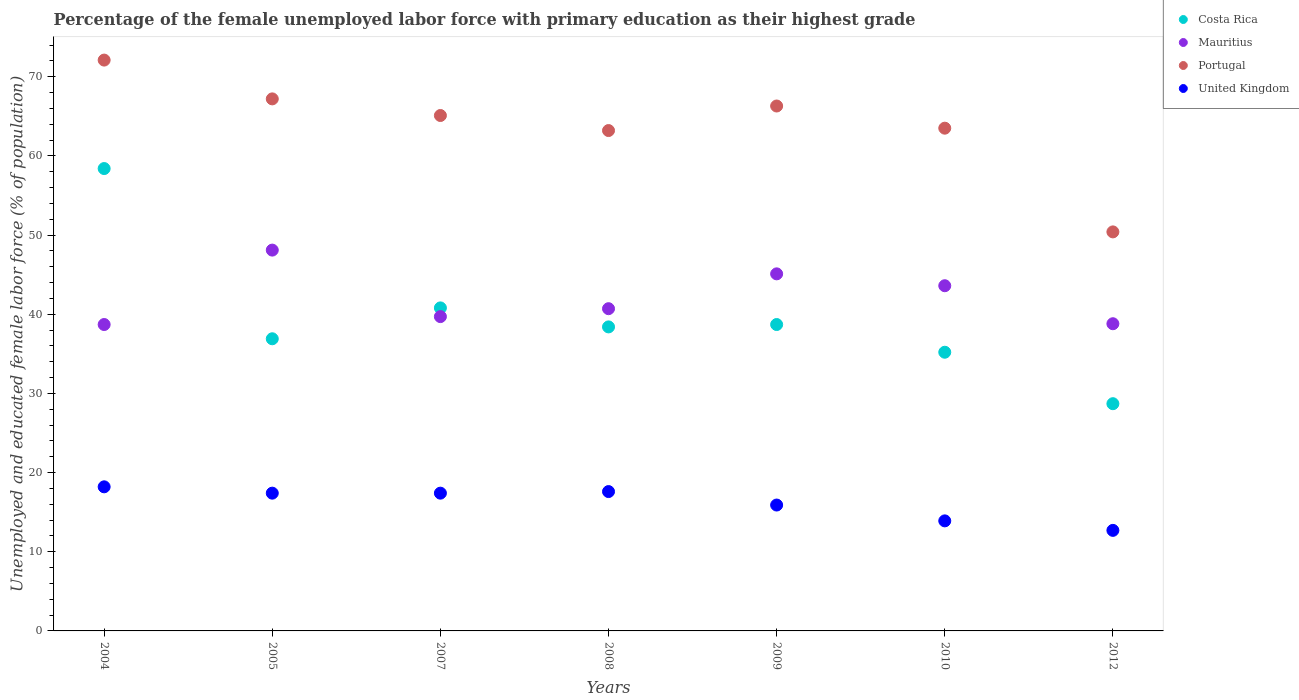How many different coloured dotlines are there?
Your answer should be compact. 4. What is the percentage of the unemployed female labor force with primary education in Mauritius in 2010?
Your answer should be very brief. 43.6. Across all years, what is the maximum percentage of the unemployed female labor force with primary education in Costa Rica?
Your answer should be compact. 58.4. Across all years, what is the minimum percentage of the unemployed female labor force with primary education in Mauritius?
Provide a succinct answer. 38.7. What is the total percentage of the unemployed female labor force with primary education in Mauritius in the graph?
Ensure brevity in your answer.  294.7. What is the difference between the percentage of the unemployed female labor force with primary education in Portugal in 2007 and that in 2009?
Your answer should be very brief. -1.2. What is the difference between the percentage of the unemployed female labor force with primary education in Costa Rica in 2008 and the percentage of the unemployed female labor force with primary education in United Kingdom in 2009?
Your response must be concise. 22.5. What is the average percentage of the unemployed female labor force with primary education in Costa Rica per year?
Keep it short and to the point. 39.59. In the year 2007, what is the difference between the percentage of the unemployed female labor force with primary education in United Kingdom and percentage of the unemployed female labor force with primary education in Portugal?
Ensure brevity in your answer.  -47.7. What is the ratio of the percentage of the unemployed female labor force with primary education in Mauritius in 2007 to that in 2008?
Your response must be concise. 0.98. Is the percentage of the unemployed female labor force with primary education in Portugal in 2004 less than that in 2008?
Make the answer very short. No. Is the difference between the percentage of the unemployed female labor force with primary education in United Kingdom in 2004 and 2005 greater than the difference between the percentage of the unemployed female labor force with primary education in Portugal in 2004 and 2005?
Your response must be concise. No. What is the difference between the highest and the second highest percentage of the unemployed female labor force with primary education in Costa Rica?
Provide a succinct answer. 17.6. What is the difference between the highest and the lowest percentage of the unemployed female labor force with primary education in United Kingdom?
Give a very brief answer. 5.5. Is it the case that in every year, the sum of the percentage of the unemployed female labor force with primary education in Mauritius and percentage of the unemployed female labor force with primary education in United Kingdom  is greater than the sum of percentage of the unemployed female labor force with primary education in Portugal and percentage of the unemployed female labor force with primary education in Costa Rica?
Provide a short and direct response. No. Are the values on the major ticks of Y-axis written in scientific E-notation?
Make the answer very short. No. Does the graph contain grids?
Offer a very short reply. No. Where does the legend appear in the graph?
Make the answer very short. Top right. How are the legend labels stacked?
Offer a very short reply. Vertical. What is the title of the graph?
Give a very brief answer. Percentage of the female unemployed labor force with primary education as their highest grade. What is the label or title of the Y-axis?
Ensure brevity in your answer.  Unemployed and educated female labor force (% of population). What is the Unemployed and educated female labor force (% of population) of Costa Rica in 2004?
Make the answer very short. 58.4. What is the Unemployed and educated female labor force (% of population) in Mauritius in 2004?
Your answer should be compact. 38.7. What is the Unemployed and educated female labor force (% of population) in Portugal in 2004?
Make the answer very short. 72.1. What is the Unemployed and educated female labor force (% of population) of United Kingdom in 2004?
Make the answer very short. 18.2. What is the Unemployed and educated female labor force (% of population) in Costa Rica in 2005?
Offer a very short reply. 36.9. What is the Unemployed and educated female labor force (% of population) in Mauritius in 2005?
Make the answer very short. 48.1. What is the Unemployed and educated female labor force (% of population) in Portugal in 2005?
Give a very brief answer. 67.2. What is the Unemployed and educated female labor force (% of population) in United Kingdom in 2005?
Provide a succinct answer. 17.4. What is the Unemployed and educated female labor force (% of population) in Costa Rica in 2007?
Make the answer very short. 40.8. What is the Unemployed and educated female labor force (% of population) of Mauritius in 2007?
Your response must be concise. 39.7. What is the Unemployed and educated female labor force (% of population) of Portugal in 2007?
Give a very brief answer. 65.1. What is the Unemployed and educated female labor force (% of population) in United Kingdom in 2007?
Your response must be concise. 17.4. What is the Unemployed and educated female labor force (% of population) of Costa Rica in 2008?
Give a very brief answer. 38.4. What is the Unemployed and educated female labor force (% of population) of Mauritius in 2008?
Your answer should be very brief. 40.7. What is the Unemployed and educated female labor force (% of population) in Portugal in 2008?
Make the answer very short. 63.2. What is the Unemployed and educated female labor force (% of population) of United Kingdom in 2008?
Your response must be concise. 17.6. What is the Unemployed and educated female labor force (% of population) of Costa Rica in 2009?
Provide a short and direct response. 38.7. What is the Unemployed and educated female labor force (% of population) in Mauritius in 2009?
Give a very brief answer. 45.1. What is the Unemployed and educated female labor force (% of population) in Portugal in 2009?
Your answer should be compact. 66.3. What is the Unemployed and educated female labor force (% of population) in United Kingdom in 2009?
Provide a succinct answer. 15.9. What is the Unemployed and educated female labor force (% of population) in Costa Rica in 2010?
Offer a terse response. 35.2. What is the Unemployed and educated female labor force (% of population) of Mauritius in 2010?
Offer a very short reply. 43.6. What is the Unemployed and educated female labor force (% of population) in Portugal in 2010?
Ensure brevity in your answer.  63.5. What is the Unemployed and educated female labor force (% of population) in United Kingdom in 2010?
Provide a succinct answer. 13.9. What is the Unemployed and educated female labor force (% of population) in Costa Rica in 2012?
Make the answer very short. 28.7. What is the Unemployed and educated female labor force (% of population) in Mauritius in 2012?
Offer a very short reply. 38.8. What is the Unemployed and educated female labor force (% of population) in Portugal in 2012?
Give a very brief answer. 50.4. What is the Unemployed and educated female labor force (% of population) of United Kingdom in 2012?
Keep it short and to the point. 12.7. Across all years, what is the maximum Unemployed and educated female labor force (% of population) of Costa Rica?
Make the answer very short. 58.4. Across all years, what is the maximum Unemployed and educated female labor force (% of population) in Mauritius?
Ensure brevity in your answer.  48.1. Across all years, what is the maximum Unemployed and educated female labor force (% of population) in Portugal?
Provide a short and direct response. 72.1. Across all years, what is the maximum Unemployed and educated female labor force (% of population) of United Kingdom?
Give a very brief answer. 18.2. Across all years, what is the minimum Unemployed and educated female labor force (% of population) in Costa Rica?
Keep it short and to the point. 28.7. Across all years, what is the minimum Unemployed and educated female labor force (% of population) of Mauritius?
Give a very brief answer. 38.7. Across all years, what is the minimum Unemployed and educated female labor force (% of population) in Portugal?
Your response must be concise. 50.4. Across all years, what is the minimum Unemployed and educated female labor force (% of population) of United Kingdom?
Ensure brevity in your answer.  12.7. What is the total Unemployed and educated female labor force (% of population) in Costa Rica in the graph?
Your answer should be very brief. 277.1. What is the total Unemployed and educated female labor force (% of population) in Mauritius in the graph?
Provide a short and direct response. 294.7. What is the total Unemployed and educated female labor force (% of population) in Portugal in the graph?
Keep it short and to the point. 447.8. What is the total Unemployed and educated female labor force (% of population) in United Kingdom in the graph?
Your answer should be very brief. 113.1. What is the difference between the Unemployed and educated female labor force (% of population) in Costa Rica in 2004 and that in 2005?
Provide a succinct answer. 21.5. What is the difference between the Unemployed and educated female labor force (% of population) of Mauritius in 2004 and that in 2005?
Give a very brief answer. -9.4. What is the difference between the Unemployed and educated female labor force (% of population) of United Kingdom in 2004 and that in 2005?
Provide a short and direct response. 0.8. What is the difference between the Unemployed and educated female labor force (% of population) in Mauritius in 2004 and that in 2007?
Offer a very short reply. -1. What is the difference between the Unemployed and educated female labor force (% of population) in United Kingdom in 2004 and that in 2007?
Offer a very short reply. 0.8. What is the difference between the Unemployed and educated female labor force (% of population) in United Kingdom in 2004 and that in 2008?
Keep it short and to the point. 0.6. What is the difference between the Unemployed and educated female labor force (% of population) in United Kingdom in 2004 and that in 2009?
Your answer should be very brief. 2.3. What is the difference between the Unemployed and educated female labor force (% of population) in Costa Rica in 2004 and that in 2010?
Offer a terse response. 23.2. What is the difference between the Unemployed and educated female labor force (% of population) in Mauritius in 2004 and that in 2010?
Give a very brief answer. -4.9. What is the difference between the Unemployed and educated female labor force (% of population) in Portugal in 2004 and that in 2010?
Your answer should be compact. 8.6. What is the difference between the Unemployed and educated female labor force (% of population) in Costa Rica in 2004 and that in 2012?
Provide a succinct answer. 29.7. What is the difference between the Unemployed and educated female labor force (% of population) in Portugal in 2004 and that in 2012?
Offer a terse response. 21.7. What is the difference between the Unemployed and educated female labor force (% of population) in United Kingdom in 2004 and that in 2012?
Ensure brevity in your answer.  5.5. What is the difference between the Unemployed and educated female labor force (% of population) of Mauritius in 2005 and that in 2007?
Keep it short and to the point. 8.4. What is the difference between the Unemployed and educated female labor force (% of population) in Portugal in 2005 and that in 2007?
Provide a succinct answer. 2.1. What is the difference between the Unemployed and educated female labor force (% of population) of United Kingdom in 2005 and that in 2007?
Provide a short and direct response. 0. What is the difference between the Unemployed and educated female labor force (% of population) in Mauritius in 2005 and that in 2008?
Your response must be concise. 7.4. What is the difference between the Unemployed and educated female labor force (% of population) in Portugal in 2005 and that in 2008?
Give a very brief answer. 4. What is the difference between the Unemployed and educated female labor force (% of population) in United Kingdom in 2005 and that in 2008?
Offer a very short reply. -0.2. What is the difference between the Unemployed and educated female labor force (% of population) in Mauritius in 2005 and that in 2010?
Make the answer very short. 4.5. What is the difference between the Unemployed and educated female labor force (% of population) in Portugal in 2005 and that in 2010?
Provide a succinct answer. 3.7. What is the difference between the Unemployed and educated female labor force (% of population) of United Kingdom in 2005 and that in 2010?
Make the answer very short. 3.5. What is the difference between the Unemployed and educated female labor force (% of population) of Costa Rica in 2005 and that in 2012?
Keep it short and to the point. 8.2. What is the difference between the Unemployed and educated female labor force (% of population) of Portugal in 2005 and that in 2012?
Give a very brief answer. 16.8. What is the difference between the Unemployed and educated female labor force (% of population) of United Kingdom in 2005 and that in 2012?
Offer a very short reply. 4.7. What is the difference between the Unemployed and educated female labor force (% of population) in Costa Rica in 2007 and that in 2010?
Offer a terse response. 5.6. What is the difference between the Unemployed and educated female labor force (% of population) in Mauritius in 2007 and that in 2010?
Provide a succinct answer. -3.9. What is the difference between the Unemployed and educated female labor force (% of population) in Portugal in 2007 and that in 2010?
Keep it short and to the point. 1.6. What is the difference between the Unemployed and educated female labor force (% of population) of United Kingdom in 2007 and that in 2010?
Ensure brevity in your answer.  3.5. What is the difference between the Unemployed and educated female labor force (% of population) of Mauritius in 2007 and that in 2012?
Give a very brief answer. 0.9. What is the difference between the Unemployed and educated female labor force (% of population) in Portugal in 2007 and that in 2012?
Your answer should be very brief. 14.7. What is the difference between the Unemployed and educated female labor force (% of population) in United Kingdom in 2007 and that in 2012?
Offer a terse response. 4.7. What is the difference between the Unemployed and educated female labor force (% of population) of Mauritius in 2008 and that in 2009?
Provide a succinct answer. -4.4. What is the difference between the Unemployed and educated female labor force (% of population) of Mauritius in 2008 and that in 2010?
Ensure brevity in your answer.  -2.9. What is the difference between the Unemployed and educated female labor force (% of population) of United Kingdom in 2008 and that in 2010?
Offer a terse response. 3.7. What is the difference between the Unemployed and educated female labor force (% of population) in Mauritius in 2008 and that in 2012?
Your answer should be very brief. 1.9. What is the difference between the Unemployed and educated female labor force (% of population) of Portugal in 2008 and that in 2012?
Offer a very short reply. 12.8. What is the difference between the Unemployed and educated female labor force (% of population) in United Kingdom in 2008 and that in 2012?
Give a very brief answer. 4.9. What is the difference between the Unemployed and educated female labor force (% of population) in Costa Rica in 2009 and that in 2010?
Offer a very short reply. 3.5. What is the difference between the Unemployed and educated female labor force (% of population) of Mauritius in 2009 and that in 2010?
Give a very brief answer. 1.5. What is the difference between the Unemployed and educated female labor force (% of population) in Portugal in 2009 and that in 2010?
Your answer should be very brief. 2.8. What is the difference between the Unemployed and educated female labor force (% of population) in Costa Rica in 2010 and that in 2012?
Offer a terse response. 6.5. What is the difference between the Unemployed and educated female labor force (% of population) of Portugal in 2010 and that in 2012?
Offer a very short reply. 13.1. What is the difference between the Unemployed and educated female labor force (% of population) of United Kingdom in 2010 and that in 2012?
Give a very brief answer. 1.2. What is the difference between the Unemployed and educated female labor force (% of population) of Mauritius in 2004 and the Unemployed and educated female labor force (% of population) of Portugal in 2005?
Give a very brief answer. -28.5. What is the difference between the Unemployed and educated female labor force (% of population) of Mauritius in 2004 and the Unemployed and educated female labor force (% of population) of United Kingdom in 2005?
Your answer should be very brief. 21.3. What is the difference between the Unemployed and educated female labor force (% of population) in Portugal in 2004 and the Unemployed and educated female labor force (% of population) in United Kingdom in 2005?
Offer a very short reply. 54.7. What is the difference between the Unemployed and educated female labor force (% of population) of Costa Rica in 2004 and the Unemployed and educated female labor force (% of population) of Mauritius in 2007?
Offer a terse response. 18.7. What is the difference between the Unemployed and educated female labor force (% of population) in Costa Rica in 2004 and the Unemployed and educated female labor force (% of population) in Portugal in 2007?
Provide a short and direct response. -6.7. What is the difference between the Unemployed and educated female labor force (% of population) of Costa Rica in 2004 and the Unemployed and educated female labor force (% of population) of United Kingdom in 2007?
Provide a succinct answer. 41. What is the difference between the Unemployed and educated female labor force (% of population) of Mauritius in 2004 and the Unemployed and educated female labor force (% of population) of Portugal in 2007?
Your answer should be very brief. -26.4. What is the difference between the Unemployed and educated female labor force (% of population) of Mauritius in 2004 and the Unemployed and educated female labor force (% of population) of United Kingdom in 2007?
Your response must be concise. 21.3. What is the difference between the Unemployed and educated female labor force (% of population) of Portugal in 2004 and the Unemployed and educated female labor force (% of population) of United Kingdom in 2007?
Your answer should be very brief. 54.7. What is the difference between the Unemployed and educated female labor force (% of population) of Costa Rica in 2004 and the Unemployed and educated female labor force (% of population) of Mauritius in 2008?
Provide a short and direct response. 17.7. What is the difference between the Unemployed and educated female labor force (% of population) of Costa Rica in 2004 and the Unemployed and educated female labor force (% of population) of United Kingdom in 2008?
Offer a very short reply. 40.8. What is the difference between the Unemployed and educated female labor force (% of population) of Mauritius in 2004 and the Unemployed and educated female labor force (% of population) of Portugal in 2008?
Your answer should be compact. -24.5. What is the difference between the Unemployed and educated female labor force (% of population) of Mauritius in 2004 and the Unemployed and educated female labor force (% of population) of United Kingdom in 2008?
Your response must be concise. 21.1. What is the difference between the Unemployed and educated female labor force (% of population) of Portugal in 2004 and the Unemployed and educated female labor force (% of population) of United Kingdom in 2008?
Your response must be concise. 54.5. What is the difference between the Unemployed and educated female labor force (% of population) in Costa Rica in 2004 and the Unemployed and educated female labor force (% of population) in Mauritius in 2009?
Give a very brief answer. 13.3. What is the difference between the Unemployed and educated female labor force (% of population) in Costa Rica in 2004 and the Unemployed and educated female labor force (% of population) in United Kingdom in 2009?
Your response must be concise. 42.5. What is the difference between the Unemployed and educated female labor force (% of population) of Mauritius in 2004 and the Unemployed and educated female labor force (% of population) of Portugal in 2009?
Provide a succinct answer. -27.6. What is the difference between the Unemployed and educated female labor force (% of population) in Mauritius in 2004 and the Unemployed and educated female labor force (% of population) in United Kingdom in 2009?
Offer a very short reply. 22.8. What is the difference between the Unemployed and educated female labor force (% of population) of Portugal in 2004 and the Unemployed and educated female labor force (% of population) of United Kingdom in 2009?
Make the answer very short. 56.2. What is the difference between the Unemployed and educated female labor force (% of population) in Costa Rica in 2004 and the Unemployed and educated female labor force (% of population) in Portugal in 2010?
Provide a short and direct response. -5.1. What is the difference between the Unemployed and educated female labor force (% of population) in Costa Rica in 2004 and the Unemployed and educated female labor force (% of population) in United Kingdom in 2010?
Your answer should be compact. 44.5. What is the difference between the Unemployed and educated female labor force (% of population) of Mauritius in 2004 and the Unemployed and educated female labor force (% of population) of Portugal in 2010?
Provide a succinct answer. -24.8. What is the difference between the Unemployed and educated female labor force (% of population) of Mauritius in 2004 and the Unemployed and educated female labor force (% of population) of United Kingdom in 2010?
Keep it short and to the point. 24.8. What is the difference between the Unemployed and educated female labor force (% of population) in Portugal in 2004 and the Unemployed and educated female labor force (% of population) in United Kingdom in 2010?
Your answer should be compact. 58.2. What is the difference between the Unemployed and educated female labor force (% of population) in Costa Rica in 2004 and the Unemployed and educated female labor force (% of population) in Mauritius in 2012?
Your response must be concise. 19.6. What is the difference between the Unemployed and educated female labor force (% of population) of Costa Rica in 2004 and the Unemployed and educated female labor force (% of population) of Portugal in 2012?
Offer a terse response. 8. What is the difference between the Unemployed and educated female labor force (% of population) in Costa Rica in 2004 and the Unemployed and educated female labor force (% of population) in United Kingdom in 2012?
Ensure brevity in your answer.  45.7. What is the difference between the Unemployed and educated female labor force (% of population) of Portugal in 2004 and the Unemployed and educated female labor force (% of population) of United Kingdom in 2012?
Your response must be concise. 59.4. What is the difference between the Unemployed and educated female labor force (% of population) in Costa Rica in 2005 and the Unemployed and educated female labor force (% of population) in Mauritius in 2007?
Your answer should be compact. -2.8. What is the difference between the Unemployed and educated female labor force (% of population) in Costa Rica in 2005 and the Unemployed and educated female labor force (% of population) in Portugal in 2007?
Provide a succinct answer. -28.2. What is the difference between the Unemployed and educated female labor force (% of population) in Mauritius in 2005 and the Unemployed and educated female labor force (% of population) in United Kingdom in 2007?
Your answer should be very brief. 30.7. What is the difference between the Unemployed and educated female labor force (% of population) in Portugal in 2005 and the Unemployed and educated female labor force (% of population) in United Kingdom in 2007?
Keep it short and to the point. 49.8. What is the difference between the Unemployed and educated female labor force (% of population) in Costa Rica in 2005 and the Unemployed and educated female labor force (% of population) in Mauritius in 2008?
Ensure brevity in your answer.  -3.8. What is the difference between the Unemployed and educated female labor force (% of population) of Costa Rica in 2005 and the Unemployed and educated female labor force (% of population) of Portugal in 2008?
Provide a succinct answer. -26.3. What is the difference between the Unemployed and educated female labor force (% of population) of Costa Rica in 2005 and the Unemployed and educated female labor force (% of population) of United Kingdom in 2008?
Provide a short and direct response. 19.3. What is the difference between the Unemployed and educated female labor force (% of population) of Mauritius in 2005 and the Unemployed and educated female labor force (% of population) of Portugal in 2008?
Make the answer very short. -15.1. What is the difference between the Unemployed and educated female labor force (% of population) of Mauritius in 2005 and the Unemployed and educated female labor force (% of population) of United Kingdom in 2008?
Keep it short and to the point. 30.5. What is the difference between the Unemployed and educated female labor force (% of population) of Portugal in 2005 and the Unemployed and educated female labor force (% of population) of United Kingdom in 2008?
Offer a very short reply. 49.6. What is the difference between the Unemployed and educated female labor force (% of population) in Costa Rica in 2005 and the Unemployed and educated female labor force (% of population) in Portugal in 2009?
Offer a terse response. -29.4. What is the difference between the Unemployed and educated female labor force (% of population) of Costa Rica in 2005 and the Unemployed and educated female labor force (% of population) of United Kingdom in 2009?
Your answer should be compact. 21. What is the difference between the Unemployed and educated female labor force (% of population) in Mauritius in 2005 and the Unemployed and educated female labor force (% of population) in Portugal in 2009?
Offer a very short reply. -18.2. What is the difference between the Unemployed and educated female labor force (% of population) in Mauritius in 2005 and the Unemployed and educated female labor force (% of population) in United Kingdom in 2009?
Your answer should be very brief. 32.2. What is the difference between the Unemployed and educated female labor force (% of population) in Portugal in 2005 and the Unemployed and educated female labor force (% of population) in United Kingdom in 2009?
Make the answer very short. 51.3. What is the difference between the Unemployed and educated female labor force (% of population) in Costa Rica in 2005 and the Unemployed and educated female labor force (% of population) in Portugal in 2010?
Make the answer very short. -26.6. What is the difference between the Unemployed and educated female labor force (% of population) of Costa Rica in 2005 and the Unemployed and educated female labor force (% of population) of United Kingdom in 2010?
Your response must be concise. 23. What is the difference between the Unemployed and educated female labor force (% of population) in Mauritius in 2005 and the Unemployed and educated female labor force (% of population) in Portugal in 2010?
Make the answer very short. -15.4. What is the difference between the Unemployed and educated female labor force (% of population) of Mauritius in 2005 and the Unemployed and educated female labor force (% of population) of United Kingdom in 2010?
Your answer should be very brief. 34.2. What is the difference between the Unemployed and educated female labor force (% of population) of Portugal in 2005 and the Unemployed and educated female labor force (% of population) of United Kingdom in 2010?
Keep it short and to the point. 53.3. What is the difference between the Unemployed and educated female labor force (% of population) in Costa Rica in 2005 and the Unemployed and educated female labor force (% of population) in Mauritius in 2012?
Offer a terse response. -1.9. What is the difference between the Unemployed and educated female labor force (% of population) in Costa Rica in 2005 and the Unemployed and educated female labor force (% of population) in Portugal in 2012?
Offer a very short reply. -13.5. What is the difference between the Unemployed and educated female labor force (% of population) of Costa Rica in 2005 and the Unemployed and educated female labor force (% of population) of United Kingdom in 2012?
Offer a terse response. 24.2. What is the difference between the Unemployed and educated female labor force (% of population) of Mauritius in 2005 and the Unemployed and educated female labor force (% of population) of United Kingdom in 2012?
Provide a short and direct response. 35.4. What is the difference between the Unemployed and educated female labor force (% of population) in Portugal in 2005 and the Unemployed and educated female labor force (% of population) in United Kingdom in 2012?
Your response must be concise. 54.5. What is the difference between the Unemployed and educated female labor force (% of population) of Costa Rica in 2007 and the Unemployed and educated female labor force (% of population) of Mauritius in 2008?
Provide a succinct answer. 0.1. What is the difference between the Unemployed and educated female labor force (% of population) of Costa Rica in 2007 and the Unemployed and educated female labor force (% of population) of Portugal in 2008?
Your response must be concise. -22.4. What is the difference between the Unemployed and educated female labor force (% of population) in Costa Rica in 2007 and the Unemployed and educated female labor force (% of population) in United Kingdom in 2008?
Make the answer very short. 23.2. What is the difference between the Unemployed and educated female labor force (% of population) in Mauritius in 2007 and the Unemployed and educated female labor force (% of population) in Portugal in 2008?
Provide a short and direct response. -23.5. What is the difference between the Unemployed and educated female labor force (% of population) in Mauritius in 2007 and the Unemployed and educated female labor force (% of population) in United Kingdom in 2008?
Provide a succinct answer. 22.1. What is the difference between the Unemployed and educated female labor force (% of population) of Portugal in 2007 and the Unemployed and educated female labor force (% of population) of United Kingdom in 2008?
Your answer should be compact. 47.5. What is the difference between the Unemployed and educated female labor force (% of population) of Costa Rica in 2007 and the Unemployed and educated female labor force (% of population) of Portugal in 2009?
Provide a succinct answer. -25.5. What is the difference between the Unemployed and educated female labor force (% of population) of Costa Rica in 2007 and the Unemployed and educated female labor force (% of population) of United Kingdom in 2009?
Keep it short and to the point. 24.9. What is the difference between the Unemployed and educated female labor force (% of population) of Mauritius in 2007 and the Unemployed and educated female labor force (% of population) of Portugal in 2009?
Your answer should be very brief. -26.6. What is the difference between the Unemployed and educated female labor force (% of population) in Mauritius in 2007 and the Unemployed and educated female labor force (% of population) in United Kingdom in 2009?
Your response must be concise. 23.8. What is the difference between the Unemployed and educated female labor force (% of population) of Portugal in 2007 and the Unemployed and educated female labor force (% of population) of United Kingdom in 2009?
Provide a short and direct response. 49.2. What is the difference between the Unemployed and educated female labor force (% of population) of Costa Rica in 2007 and the Unemployed and educated female labor force (% of population) of Portugal in 2010?
Offer a very short reply. -22.7. What is the difference between the Unemployed and educated female labor force (% of population) in Costa Rica in 2007 and the Unemployed and educated female labor force (% of population) in United Kingdom in 2010?
Ensure brevity in your answer.  26.9. What is the difference between the Unemployed and educated female labor force (% of population) in Mauritius in 2007 and the Unemployed and educated female labor force (% of population) in Portugal in 2010?
Keep it short and to the point. -23.8. What is the difference between the Unemployed and educated female labor force (% of population) of Mauritius in 2007 and the Unemployed and educated female labor force (% of population) of United Kingdom in 2010?
Your answer should be very brief. 25.8. What is the difference between the Unemployed and educated female labor force (% of population) of Portugal in 2007 and the Unemployed and educated female labor force (% of population) of United Kingdom in 2010?
Provide a short and direct response. 51.2. What is the difference between the Unemployed and educated female labor force (% of population) of Costa Rica in 2007 and the Unemployed and educated female labor force (% of population) of Mauritius in 2012?
Offer a terse response. 2. What is the difference between the Unemployed and educated female labor force (% of population) in Costa Rica in 2007 and the Unemployed and educated female labor force (% of population) in Portugal in 2012?
Your response must be concise. -9.6. What is the difference between the Unemployed and educated female labor force (% of population) of Costa Rica in 2007 and the Unemployed and educated female labor force (% of population) of United Kingdom in 2012?
Your response must be concise. 28.1. What is the difference between the Unemployed and educated female labor force (% of population) of Mauritius in 2007 and the Unemployed and educated female labor force (% of population) of Portugal in 2012?
Ensure brevity in your answer.  -10.7. What is the difference between the Unemployed and educated female labor force (% of population) of Portugal in 2007 and the Unemployed and educated female labor force (% of population) of United Kingdom in 2012?
Keep it short and to the point. 52.4. What is the difference between the Unemployed and educated female labor force (% of population) in Costa Rica in 2008 and the Unemployed and educated female labor force (% of population) in Portugal in 2009?
Offer a terse response. -27.9. What is the difference between the Unemployed and educated female labor force (% of population) in Costa Rica in 2008 and the Unemployed and educated female labor force (% of population) in United Kingdom in 2009?
Provide a succinct answer. 22.5. What is the difference between the Unemployed and educated female labor force (% of population) of Mauritius in 2008 and the Unemployed and educated female labor force (% of population) of Portugal in 2009?
Provide a short and direct response. -25.6. What is the difference between the Unemployed and educated female labor force (% of population) in Mauritius in 2008 and the Unemployed and educated female labor force (% of population) in United Kingdom in 2009?
Keep it short and to the point. 24.8. What is the difference between the Unemployed and educated female labor force (% of population) in Portugal in 2008 and the Unemployed and educated female labor force (% of population) in United Kingdom in 2009?
Provide a short and direct response. 47.3. What is the difference between the Unemployed and educated female labor force (% of population) in Costa Rica in 2008 and the Unemployed and educated female labor force (% of population) in Mauritius in 2010?
Offer a terse response. -5.2. What is the difference between the Unemployed and educated female labor force (% of population) in Costa Rica in 2008 and the Unemployed and educated female labor force (% of population) in Portugal in 2010?
Provide a short and direct response. -25.1. What is the difference between the Unemployed and educated female labor force (% of population) of Mauritius in 2008 and the Unemployed and educated female labor force (% of population) of Portugal in 2010?
Provide a succinct answer. -22.8. What is the difference between the Unemployed and educated female labor force (% of population) of Mauritius in 2008 and the Unemployed and educated female labor force (% of population) of United Kingdom in 2010?
Offer a very short reply. 26.8. What is the difference between the Unemployed and educated female labor force (% of population) of Portugal in 2008 and the Unemployed and educated female labor force (% of population) of United Kingdom in 2010?
Your answer should be compact. 49.3. What is the difference between the Unemployed and educated female labor force (% of population) in Costa Rica in 2008 and the Unemployed and educated female labor force (% of population) in United Kingdom in 2012?
Offer a very short reply. 25.7. What is the difference between the Unemployed and educated female labor force (% of population) of Portugal in 2008 and the Unemployed and educated female labor force (% of population) of United Kingdom in 2012?
Offer a terse response. 50.5. What is the difference between the Unemployed and educated female labor force (% of population) in Costa Rica in 2009 and the Unemployed and educated female labor force (% of population) in Portugal in 2010?
Your answer should be very brief. -24.8. What is the difference between the Unemployed and educated female labor force (% of population) in Costa Rica in 2009 and the Unemployed and educated female labor force (% of population) in United Kingdom in 2010?
Make the answer very short. 24.8. What is the difference between the Unemployed and educated female labor force (% of population) of Mauritius in 2009 and the Unemployed and educated female labor force (% of population) of Portugal in 2010?
Offer a terse response. -18.4. What is the difference between the Unemployed and educated female labor force (% of population) in Mauritius in 2009 and the Unemployed and educated female labor force (% of population) in United Kingdom in 2010?
Your response must be concise. 31.2. What is the difference between the Unemployed and educated female labor force (% of population) of Portugal in 2009 and the Unemployed and educated female labor force (% of population) of United Kingdom in 2010?
Offer a terse response. 52.4. What is the difference between the Unemployed and educated female labor force (% of population) of Costa Rica in 2009 and the Unemployed and educated female labor force (% of population) of United Kingdom in 2012?
Offer a very short reply. 26. What is the difference between the Unemployed and educated female labor force (% of population) of Mauritius in 2009 and the Unemployed and educated female labor force (% of population) of United Kingdom in 2012?
Provide a short and direct response. 32.4. What is the difference between the Unemployed and educated female labor force (% of population) of Portugal in 2009 and the Unemployed and educated female labor force (% of population) of United Kingdom in 2012?
Your response must be concise. 53.6. What is the difference between the Unemployed and educated female labor force (% of population) of Costa Rica in 2010 and the Unemployed and educated female labor force (% of population) of Portugal in 2012?
Offer a terse response. -15.2. What is the difference between the Unemployed and educated female labor force (% of population) of Mauritius in 2010 and the Unemployed and educated female labor force (% of population) of United Kingdom in 2012?
Offer a very short reply. 30.9. What is the difference between the Unemployed and educated female labor force (% of population) in Portugal in 2010 and the Unemployed and educated female labor force (% of population) in United Kingdom in 2012?
Make the answer very short. 50.8. What is the average Unemployed and educated female labor force (% of population) of Costa Rica per year?
Provide a short and direct response. 39.59. What is the average Unemployed and educated female labor force (% of population) in Mauritius per year?
Make the answer very short. 42.1. What is the average Unemployed and educated female labor force (% of population) of Portugal per year?
Offer a very short reply. 63.97. What is the average Unemployed and educated female labor force (% of population) in United Kingdom per year?
Your answer should be very brief. 16.16. In the year 2004, what is the difference between the Unemployed and educated female labor force (% of population) of Costa Rica and Unemployed and educated female labor force (% of population) of Mauritius?
Offer a terse response. 19.7. In the year 2004, what is the difference between the Unemployed and educated female labor force (% of population) in Costa Rica and Unemployed and educated female labor force (% of population) in Portugal?
Offer a very short reply. -13.7. In the year 2004, what is the difference between the Unemployed and educated female labor force (% of population) in Costa Rica and Unemployed and educated female labor force (% of population) in United Kingdom?
Make the answer very short. 40.2. In the year 2004, what is the difference between the Unemployed and educated female labor force (% of population) of Mauritius and Unemployed and educated female labor force (% of population) of Portugal?
Give a very brief answer. -33.4. In the year 2004, what is the difference between the Unemployed and educated female labor force (% of population) in Mauritius and Unemployed and educated female labor force (% of population) in United Kingdom?
Give a very brief answer. 20.5. In the year 2004, what is the difference between the Unemployed and educated female labor force (% of population) of Portugal and Unemployed and educated female labor force (% of population) of United Kingdom?
Your answer should be compact. 53.9. In the year 2005, what is the difference between the Unemployed and educated female labor force (% of population) in Costa Rica and Unemployed and educated female labor force (% of population) in Mauritius?
Make the answer very short. -11.2. In the year 2005, what is the difference between the Unemployed and educated female labor force (% of population) in Costa Rica and Unemployed and educated female labor force (% of population) in Portugal?
Provide a short and direct response. -30.3. In the year 2005, what is the difference between the Unemployed and educated female labor force (% of population) in Costa Rica and Unemployed and educated female labor force (% of population) in United Kingdom?
Offer a very short reply. 19.5. In the year 2005, what is the difference between the Unemployed and educated female labor force (% of population) of Mauritius and Unemployed and educated female labor force (% of population) of Portugal?
Offer a very short reply. -19.1. In the year 2005, what is the difference between the Unemployed and educated female labor force (% of population) in Mauritius and Unemployed and educated female labor force (% of population) in United Kingdom?
Offer a terse response. 30.7. In the year 2005, what is the difference between the Unemployed and educated female labor force (% of population) in Portugal and Unemployed and educated female labor force (% of population) in United Kingdom?
Your answer should be very brief. 49.8. In the year 2007, what is the difference between the Unemployed and educated female labor force (% of population) in Costa Rica and Unemployed and educated female labor force (% of population) in Mauritius?
Provide a short and direct response. 1.1. In the year 2007, what is the difference between the Unemployed and educated female labor force (% of population) in Costa Rica and Unemployed and educated female labor force (% of population) in Portugal?
Offer a terse response. -24.3. In the year 2007, what is the difference between the Unemployed and educated female labor force (% of population) of Costa Rica and Unemployed and educated female labor force (% of population) of United Kingdom?
Offer a very short reply. 23.4. In the year 2007, what is the difference between the Unemployed and educated female labor force (% of population) of Mauritius and Unemployed and educated female labor force (% of population) of Portugal?
Give a very brief answer. -25.4. In the year 2007, what is the difference between the Unemployed and educated female labor force (% of population) of Mauritius and Unemployed and educated female labor force (% of population) of United Kingdom?
Keep it short and to the point. 22.3. In the year 2007, what is the difference between the Unemployed and educated female labor force (% of population) of Portugal and Unemployed and educated female labor force (% of population) of United Kingdom?
Offer a very short reply. 47.7. In the year 2008, what is the difference between the Unemployed and educated female labor force (% of population) in Costa Rica and Unemployed and educated female labor force (% of population) in Mauritius?
Your answer should be compact. -2.3. In the year 2008, what is the difference between the Unemployed and educated female labor force (% of population) in Costa Rica and Unemployed and educated female labor force (% of population) in Portugal?
Your answer should be very brief. -24.8. In the year 2008, what is the difference between the Unemployed and educated female labor force (% of population) in Costa Rica and Unemployed and educated female labor force (% of population) in United Kingdom?
Provide a succinct answer. 20.8. In the year 2008, what is the difference between the Unemployed and educated female labor force (% of population) of Mauritius and Unemployed and educated female labor force (% of population) of Portugal?
Make the answer very short. -22.5. In the year 2008, what is the difference between the Unemployed and educated female labor force (% of population) in Mauritius and Unemployed and educated female labor force (% of population) in United Kingdom?
Offer a very short reply. 23.1. In the year 2008, what is the difference between the Unemployed and educated female labor force (% of population) of Portugal and Unemployed and educated female labor force (% of population) of United Kingdom?
Provide a succinct answer. 45.6. In the year 2009, what is the difference between the Unemployed and educated female labor force (% of population) in Costa Rica and Unemployed and educated female labor force (% of population) in Portugal?
Provide a short and direct response. -27.6. In the year 2009, what is the difference between the Unemployed and educated female labor force (% of population) in Costa Rica and Unemployed and educated female labor force (% of population) in United Kingdom?
Give a very brief answer. 22.8. In the year 2009, what is the difference between the Unemployed and educated female labor force (% of population) in Mauritius and Unemployed and educated female labor force (% of population) in Portugal?
Keep it short and to the point. -21.2. In the year 2009, what is the difference between the Unemployed and educated female labor force (% of population) of Mauritius and Unemployed and educated female labor force (% of population) of United Kingdom?
Ensure brevity in your answer.  29.2. In the year 2009, what is the difference between the Unemployed and educated female labor force (% of population) in Portugal and Unemployed and educated female labor force (% of population) in United Kingdom?
Your response must be concise. 50.4. In the year 2010, what is the difference between the Unemployed and educated female labor force (% of population) in Costa Rica and Unemployed and educated female labor force (% of population) in Portugal?
Your answer should be compact. -28.3. In the year 2010, what is the difference between the Unemployed and educated female labor force (% of population) of Costa Rica and Unemployed and educated female labor force (% of population) of United Kingdom?
Offer a terse response. 21.3. In the year 2010, what is the difference between the Unemployed and educated female labor force (% of population) in Mauritius and Unemployed and educated female labor force (% of population) in Portugal?
Your response must be concise. -19.9. In the year 2010, what is the difference between the Unemployed and educated female labor force (% of population) in Mauritius and Unemployed and educated female labor force (% of population) in United Kingdom?
Provide a short and direct response. 29.7. In the year 2010, what is the difference between the Unemployed and educated female labor force (% of population) in Portugal and Unemployed and educated female labor force (% of population) in United Kingdom?
Your answer should be compact. 49.6. In the year 2012, what is the difference between the Unemployed and educated female labor force (% of population) in Costa Rica and Unemployed and educated female labor force (% of population) in Portugal?
Make the answer very short. -21.7. In the year 2012, what is the difference between the Unemployed and educated female labor force (% of population) of Mauritius and Unemployed and educated female labor force (% of population) of Portugal?
Give a very brief answer. -11.6. In the year 2012, what is the difference between the Unemployed and educated female labor force (% of population) in Mauritius and Unemployed and educated female labor force (% of population) in United Kingdom?
Make the answer very short. 26.1. In the year 2012, what is the difference between the Unemployed and educated female labor force (% of population) of Portugal and Unemployed and educated female labor force (% of population) of United Kingdom?
Provide a short and direct response. 37.7. What is the ratio of the Unemployed and educated female labor force (% of population) of Costa Rica in 2004 to that in 2005?
Provide a succinct answer. 1.58. What is the ratio of the Unemployed and educated female labor force (% of population) in Mauritius in 2004 to that in 2005?
Keep it short and to the point. 0.8. What is the ratio of the Unemployed and educated female labor force (% of population) in Portugal in 2004 to that in 2005?
Your answer should be very brief. 1.07. What is the ratio of the Unemployed and educated female labor force (% of population) in United Kingdom in 2004 to that in 2005?
Provide a succinct answer. 1.05. What is the ratio of the Unemployed and educated female labor force (% of population) of Costa Rica in 2004 to that in 2007?
Offer a very short reply. 1.43. What is the ratio of the Unemployed and educated female labor force (% of population) in Mauritius in 2004 to that in 2007?
Give a very brief answer. 0.97. What is the ratio of the Unemployed and educated female labor force (% of population) of Portugal in 2004 to that in 2007?
Offer a terse response. 1.11. What is the ratio of the Unemployed and educated female labor force (% of population) in United Kingdom in 2004 to that in 2007?
Make the answer very short. 1.05. What is the ratio of the Unemployed and educated female labor force (% of population) in Costa Rica in 2004 to that in 2008?
Ensure brevity in your answer.  1.52. What is the ratio of the Unemployed and educated female labor force (% of population) of Mauritius in 2004 to that in 2008?
Your answer should be compact. 0.95. What is the ratio of the Unemployed and educated female labor force (% of population) in Portugal in 2004 to that in 2008?
Offer a very short reply. 1.14. What is the ratio of the Unemployed and educated female labor force (% of population) of United Kingdom in 2004 to that in 2008?
Make the answer very short. 1.03. What is the ratio of the Unemployed and educated female labor force (% of population) of Costa Rica in 2004 to that in 2009?
Offer a very short reply. 1.51. What is the ratio of the Unemployed and educated female labor force (% of population) in Mauritius in 2004 to that in 2009?
Offer a very short reply. 0.86. What is the ratio of the Unemployed and educated female labor force (% of population) in Portugal in 2004 to that in 2009?
Provide a short and direct response. 1.09. What is the ratio of the Unemployed and educated female labor force (% of population) of United Kingdom in 2004 to that in 2009?
Ensure brevity in your answer.  1.14. What is the ratio of the Unemployed and educated female labor force (% of population) of Costa Rica in 2004 to that in 2010?
Give a very brief answer. 1.66. What is the ratio of the Unemployed and educated female labor force (% of population) of Mauritius in 2004 to that in 2010?
Keep it short and to the point. 0.89. What is the ratio of the Unemployed and educated female labor force (% of population) of Portugal in 2004 to that in 2010?
Give a very brief answer. 1.14. What is the ratio of the Unemployed and educated female labor force (% of population) in United Kingdom in 2004 to that in 2010?
Offer a very short reply. 1.31. What is the ratio of the Unemployed and educated female labor force (% of population) of Costa Rica in 2004 to that in 2012?
Offer a terse response. 2.03. What is the ratio of the Unemployed and educated female labor force (% of population) in Mauritius in 2004 to that in 2012?
Your response must be concise. 1. What is the ratio of the Unemployed and educated female labor force (% of population) of Portugal in 2004 to that in 2012?
Make the answer very short. 1.43. What is the ratio of the Unemployed and educated female labor force (% of population) in United Kingdom in 2004 to that in 2012?
Your answer should be very brief. 1.43. What is the ratio of the Unemployed and educated female labor force (% of population) in Costa Rica in 2005 to that in 2007?
Give a very brief answer. 0.9. What is the ratio of the Unemployed and educated female labor force (% of population) in Mauritius in 2005 to that in 2007?
Offer a very short reply. 1.21. What is the ratio of the Unemployed and educated female labor force (% of population) in Portugal in 2005 to that in 2007?
Offer a very short reply. 1.03. What is the ratio of the Unemployed and educated female labor force (% of population) in United Kingdom in 2005 to that in 2007?
Your answer should be very brief. 1. What is the ratio of the Unemployed and educated female labor force (% of population) in Costa Rica in 2005 to that in 2008?
Ensure brevity in your answer.  0.96. What is the ratio of the Unemployed and educated female labor force (% of population) in Mauritius in 2005 to that in 2008?
Your answer should be compact. 1.18. What is the ratio of the Unemployed and educated female labor force (% of population) of Portugal in 2005 to that in 2008?
Provide a short and direct response. 1.06. What is the ratio of the Unemployed and educated female labor force (% of population) in United Kingdom in 2005 to that in 2008?
Your response must be concise. 0.99. What is the ratio of the Unemployed and educated female labor force (% of population) of Costa Rica in 2005 to that in 2009?
Ensure brevity in your answer.  0.95. What is the ratio of the Unemployed and educated female labor force (% of population) in Mauritius in 2005 to that in 2009?
Your answer should be very brief. 1.07. What is the ratio of the Unemployed and educated female labor force (% of population) in Portugal in 2005 to that in 2009?
Provide a succinct answer. 1.01. What is the ratio of the Unemployed and educated female labor force (% of population) in United Kingdom in 2005 to that in 2009?
Offer a terse response. 1.09. What is the ratio of the Unemployed and educated female labor force (% of population) of Costa Rica in 2005 to that in 2010?
Your response must be concise. 1.05. What is the ratio of the Unemployed and educated female labor force (% of population) of Mauritius in 2005 to that in 2010?
Give a very brief answer. 1.1. What is the ratio of the Unemployed and educated female labor force (% of population) in Portugal in 2005 to that in 2010?
Provide a succinct answer. 1.06. What is the ratio of the Unemployed and educated female labor force (% of population) of United Kingdom in 2005 to that in 2010?
Offer a terse response. 1.25. What is the ratio of the Unemployed and educated female labor force (% of population) in Mauritius in 2005 to that in 2012?
Provide a short and direct response. 1.24. What is the ratio of the Unemployed and educated female labor force (% of population) of Portugal in 2005 to that in 2012?
Provide a succinct answer. 1.33. What is the ratio of the Unemployed and educated female labor force (% of population) of United Kingdom in 2005 to that in 2012?
Provide a succinct answer. 1.37. What is the ratio of the Unemployed and educated female labor force (% of population) of Mauritius in 2007 to that in 2008?
Ensure brevity in your answer.  0.98. What is the ratio of the Unemployed and educated female labor force (% of population) of Portugal in 2007 to that in 2008?
Ensure brevity in your answer.  1.03. What is the ratio of the Unemployed and educated female labor force (% of population) of United Kingdom in 2007 to that in 2008?
Your answer should be compact. 0.99. What is the ratio of the Unemployed and educated female labor force (% of population) in Costa Rica in 2007 to that in 2009?
Offer a terse response. 1.05. What is the ratio of the Unemployed and educated female labor force (% of population) of Mauritius in 2007 to that in 2009?
Provide a succinct answer. 0.88. What is the ratio of the Unemployed and educated female labor force (% of population) of Portugal in 2007 to that in 2009?
Give a very brief answer. 0.98. What is the ratio of the Unemployed and educated female labor force (% of population) in United Kingdom in 2007 to that in 2009?
Give a very brief answer. 1.09. What is the ratio of the Unemployed and educated female labor force (% of population) of Costa Rica in 2007 to that in 2010?
Offer a terse response. 1.16. What is the ratio of the Unemployed and educated female labor force (% of population) of Mauritius in 2007 to that in 2010?
Make the answer very short. 0.91. What is the ratio of the Unemployed and educated female labor force (% of population) in Portugal in 2007 to that in 2010?
Offer a terse response. 1.03. What is the ratio of the Unemployed and educated female labor force (% of population) of United Kingdom in 2007 to that in 2010?
Provide a succinct answer. 1.25. What is the ratio of the Unemployed and educated female labor force (% of population) of Costa Rica in 2007 to that in 2012?
Make the answer very short. 1.42. What is the ratio of the Unemployed and educated female labor force (% of population) of Mauritius in 2007 to that in 2012?
Provide a short and direct response. 1.02. What is the ratio of the Unemployed and educated female labor force (% of population) in Portugal in 2007 to that in 2012?
Your answer should be very brief. 1.29. What is the ratio of the Unemployed and educated female labor force (% of population) of United Kingdom in 2007 to that in 2012?
Ensure brevity in your answer.  1.37. What is the ratio of the Unemployed and educated female labor force (% of population) in Mauritius in 2008 to that in 2009?
Ensure brevity in your answer.  0.9. What is the ratio of the Unemployed and educated female labor force (% of population) of Portugal in 2008 to that in 2009?
Keep it short and to the point. 0.95. What is the ratio of the Unemployed and educated female labor force (% of population) of United Kingdom in 2008 to that in 2009?
Keep it short and to the point. 1.11. What is the ratio of the Unemployed and educated female labor force (% of population) of Costa Rica in 2008 to that in 2010?
Make the answer very short. 1.09. What is the ratio of the Unemployed and educated female labor force (% of population) in Mauritius in 2008 to that in 2010?
Provide a short and direct response. 0.93. What is the ratio of the Unemployed and educated female labor force (% of population) in United Kingdom in 2008 to that in 2010?
Provide a short and direct response. 1.27. What is the ratio of the Unemployed and educated female labor force (% of population) of Costa Rica in 2008 to that in 2012?
Keep it short and to the point. 1.34. What is the ratio of the Unemployed and educated female labor force (% of population) of Mauritius in 2008 to that in 2012?
Your answer should be compact. 1.05. What is the ratio of the Unemployed and educated female labor force (% of population) in Portugal in 2008 to that in 2012?
Offer a very short reply. 1.25. What is the ratio of the Unemployed and educated female labor force (% of population) in United Kingdom in 2008 to that in 2012?
Your answer should be compact. 1.39. What is the ratio of the Unemployed and educated female labor force (% of population) in Costa Rica in 2009 to that in 2010?
Offer a terse response. 1.1. What is the ratio of the Unemployed and educated female labor force (% of population) of Mauritius in 2009 to that in 2010?
Your response must be concise. 1.03. What is the ratio of the Unemployed and educated female labor force (% of population) in Portugal in 2009 to that in 2010?
Provide a succinct answer. 1.04. What is the ratio of the Unemployed and educated female labor force (% of population) of United Kingdom in 2009 to that in 2010?
Provide a succinct answer. 1.14. What is the ratio of the Unemployed and educated female labor force (% of population) of Costa Rica in 2009 to that in 2012?
Ensure brevity in your answer.  1.35. What is the ratio of the Unemployed and educated female labor force (% of population) in Mauritius in 2009 to that in 2012?
Keep it short and to the point. 1.16. What is the ratio of the Unemployed and educated female labor force (% of population) of Portugal in 2009 to that in 2012?
Your response must be concise. 1.32. What is the ratio of the Unemployed and educated female labor force (% of population) of United Kingdom in 2009 to that in 2012?
Ensure brevity in your answer.  1.25. What is the ratio of the Unemployed and educated female labor force (% of population) of Costa Rica in 2010 to that in 2012?
Keep it short and to the point. 1.23. What is the ratio of the Unemployed and educated female labor force (% of population) in Mauritius in 2010 to that in 2012?
Make the answer very short. 1.12. What is the ratio of the Unemployed and educated female labor force (% of population) of Portugal in 2010 to that in 2012?
Offer a very short reply. 1.26. What is the ratio of the Unemployed and educated female labor force (% of population) in United Kingdom in 2010 to that in 2012?
Provide a succinct answer. 1.09. What is the difference between the highest and the second highest Unemployed and educated female labor force (% of population) of Mauritius?
Provide a succinct answer. 3. What is the difference between the highest and the second highest Unemployed and educated female labor force (% of population) of Portugal?
Make the answer very short. 4.9. What is the difference between the highest and the lowest Unemployed and educated female labor force (% of population) in Costa Rica?
Keep it short and to the point. 29.7. What is the difference between the highest and the lowest Unemployed and educated female labor force (% of population) of Portugal?
Your answer should be very brief. 21.7. What is the difference between the highest and the lowest Unemployed and educated female labor force (% of population) in United Kingdom?
Ensure brevity in your answer.  5.5. 